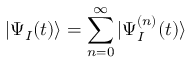Convert formula to latex. <formula><loc_0><loc_0><loc_500><loc_500>| \Psi _ { I } ( t ) \rangle = \sum _ { n = 0 } ^ { \infty } | \Psi _ { I } ^ { ( n ) } ( t ) \rangle</formula> 